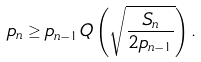Convert formula to latex. <formula><loc_0><loc_0><loc_500><loc_500>p _ { n } \geq p _ { n - 1 } Q \left ( \sqrt { \frac { S _ { n } } { 2 p _ { n - 1 } } } \right ) .</formula> 